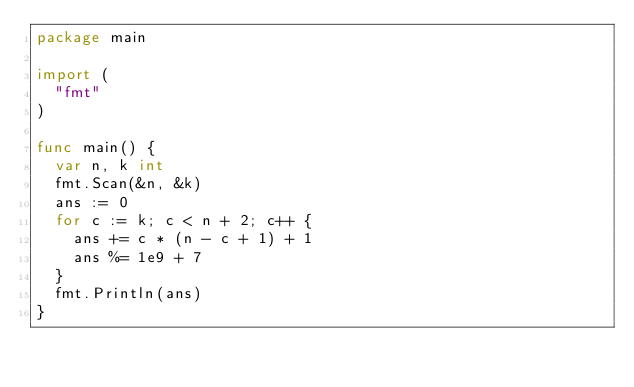Convert code to text. <code><loc_0><loc_0><loc_500><loc_500><_Go_>package main
 
import (
  "fmt"
)
 
func main() {
  var n, k int
  fmt.Scan(&n, &k)
  ans := 0
  for c := k; c < n + 2; c++ {
    ans += c * (n - c + 1) + 1
    ans %= 1e9 + 7
  }
  fmt.Println(ans)
}</code> 